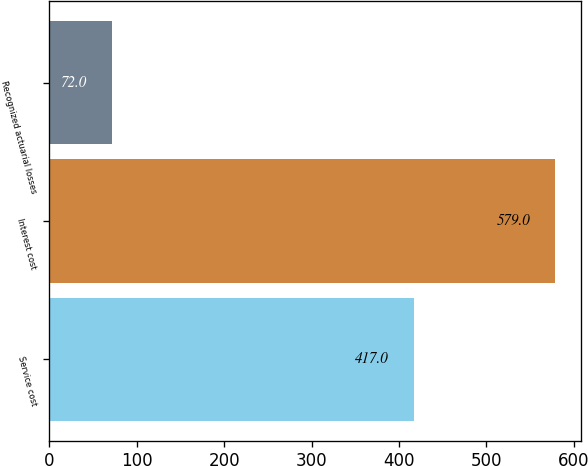<chart> <loc_0><loc_0><loc_500><loc_500><bar_chart><fcel>Service cost<fcel>Interest cost<fcel>Recognized actuarial losses<nl><fcel>417<fcel>579<fcel>72<nl></chart> 